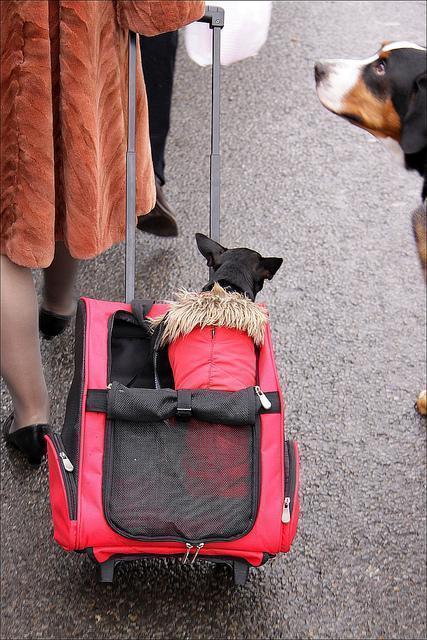What type of shoes does the woman have on?
Indicate the correct response by choosing from the four available options to answer the question.
Options: Boots, sneakers, high heels, sandals. High heels. 